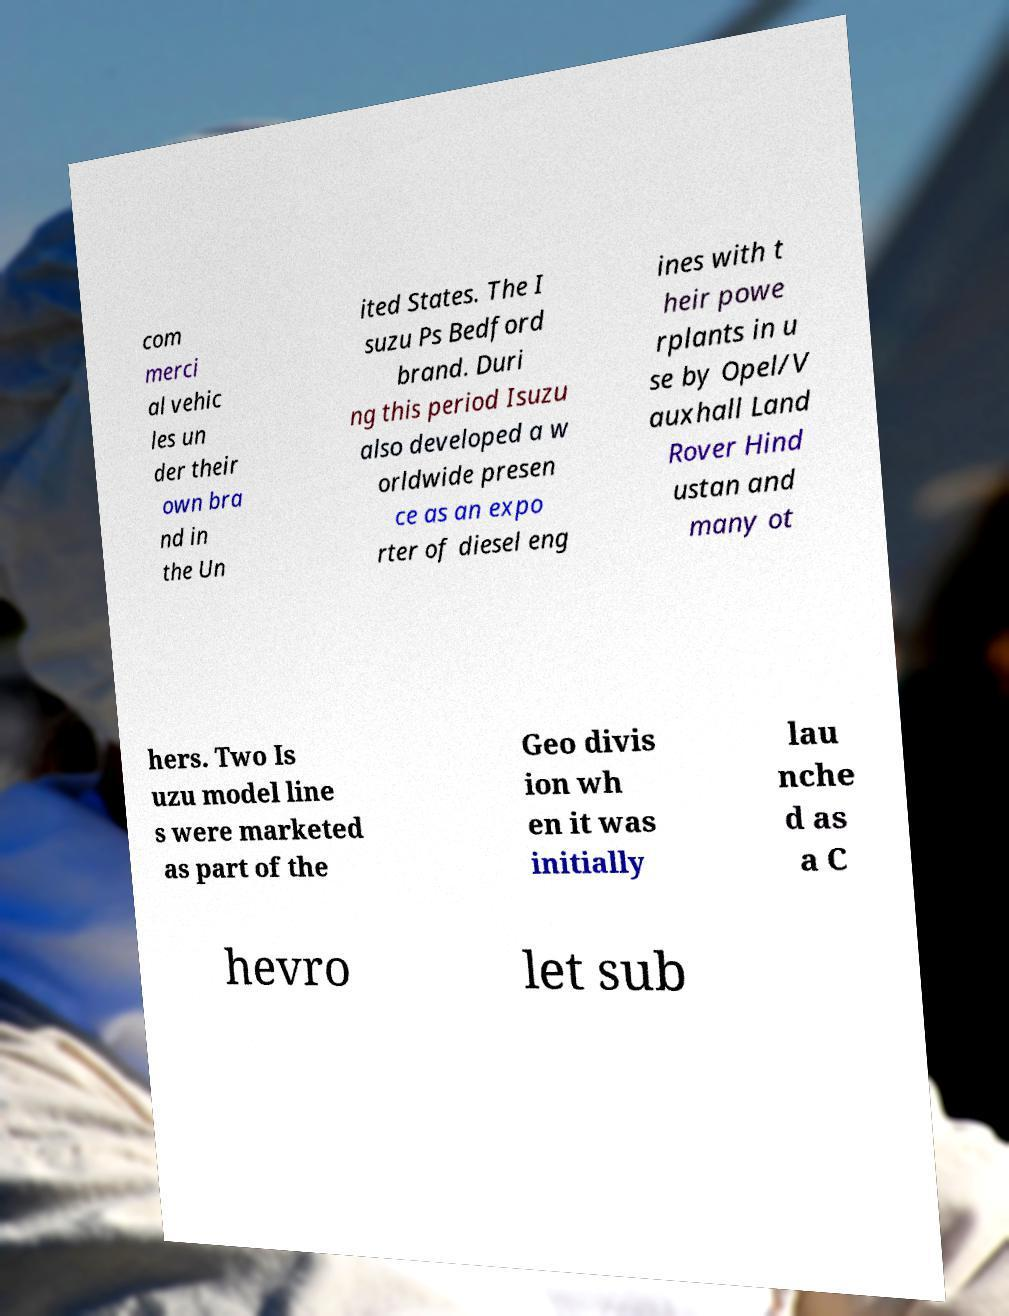Please identify and transcribe the text found in this image. com merci al vehic les un der their own bra nd in the Un ited States. The I suzu Ps Bedford brand. Duri ng this period Isuzu also developed a w orldwide presen ce as an expo rter of diesel eng ines with t heir powe rplants in u se by Opel/V auxhall Land Rover Hind ustan and many ot hers. Two Is uzu model line s were marketed as part of the Geo divis ion wh en it was initially lau nche d as a C hevro let sub 